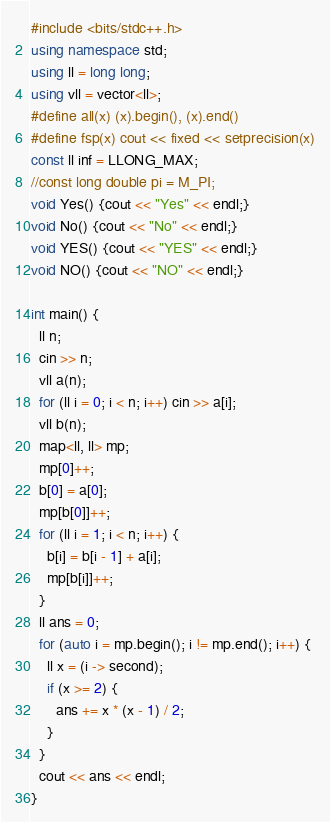Convert code to text. <code><loc_0><loc_0><loc_500><loc_500><_C++_>#include <bits/stdc++.h>
using namespace std;
using ll = long long;
using vll = vector<ll>;
#define all(x) (x).begin(), (x).end()
#define fsp(x) cout << fixed << setprecision(x)
const ll inf = LLONG_MAX;
//const long double pi = M_PI;
void Yes() {cout << "Yes" << endl;}
void No() {cout << "No" << endl;}
void YES() {cout << "YES" << endl;}
void NO() {cout << "NO" << endl;}

int main() {
  ll n;
  cin >> n;
  vll a(n);
  for (ll i = 0; i < n; i++) cin >> a[i];
  vll b(n);
  map<ll, ll> mp;
  mp[0]++;
  b[0] = a[0];
  mp[b[0]]++;
  for (ll i = 1; i < n; i++) {
    b[i] = b[i - 1] + a[i];
    mp[b[i]]++;
  }
  ll ans = 0;
  for (auto i = mp.begin(); i != mp.end(); i++) {
    ll x = (i -> second);
    if (x >= 2) {
      ans += x * (x - 1) / 2;
    }
  }
  cout << ans << endl;
}</code> 